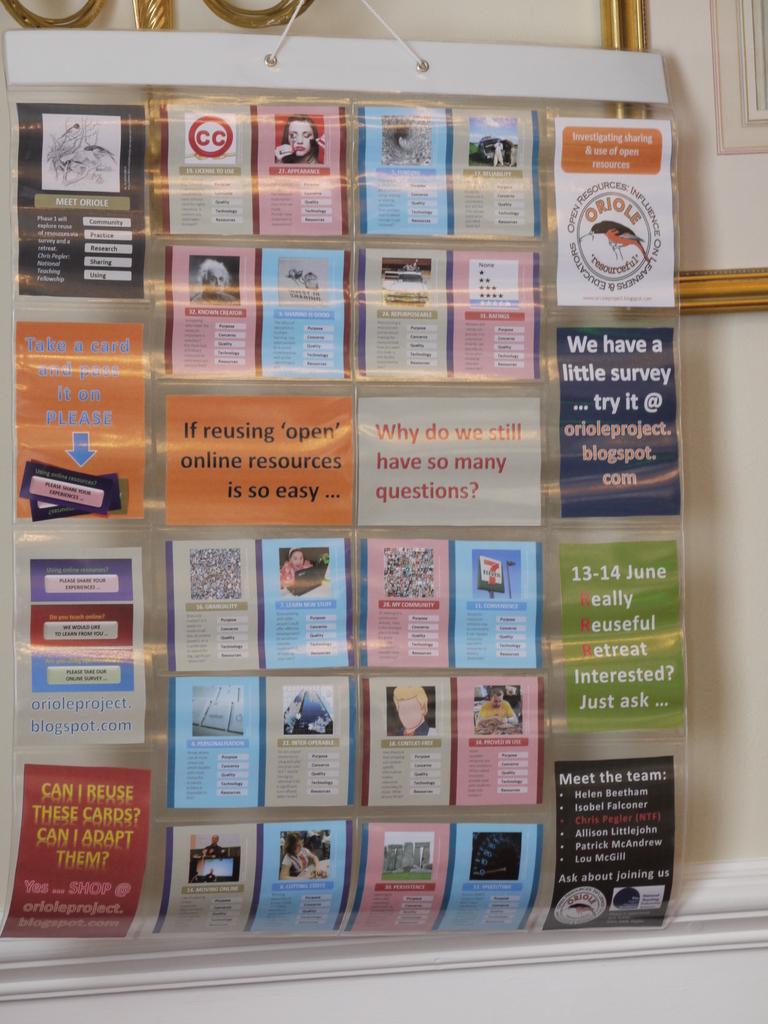What is the word in orange directly above the bird?
Provide a succinct answer. Oriole. Some lifestyle qoutes?
Offer a terse response. Yes. 